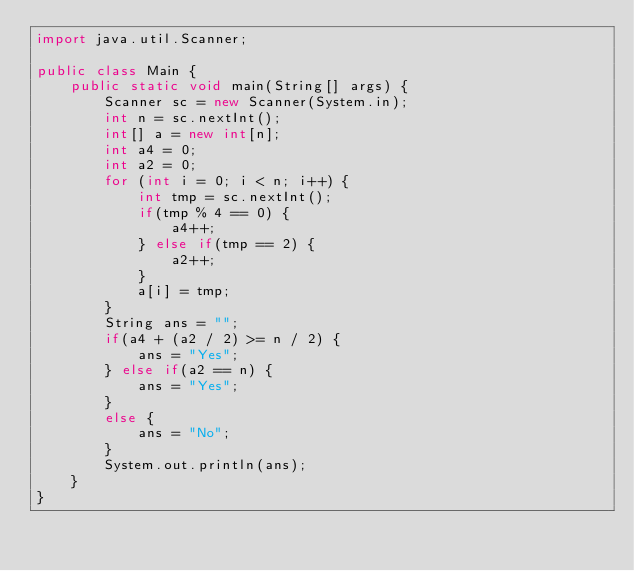<code> <loc_0><loc_0><loc_500><loc_500><_Java_>import java.util.Scanner;

public class Main {
    public static void main(String[] args) {
        Scanner sc = new Scanner(System.in);
        int n = sc.nextInt();
        int[] a = new int[n];
        int a4 = 0;
        int a2 = 0;
        for (int i = 0; i < n; i++) {
            int tmp = sc.nextInt();
            if(tmp % 4 == 0) {
                a4++;
            } else if(tmp == 2) {
                a2++;
            }
            a[i] = tmp;
        }
        String ans = "";
        if(a4 + (a2 / 2) >= n / 2) {
            ans = "Yes";
        } else if(a2 == n) {
            ans = "Yes";
        }
        else {
            ans = "No";
        }
        System.out.println(ans);
    }
}</code> 